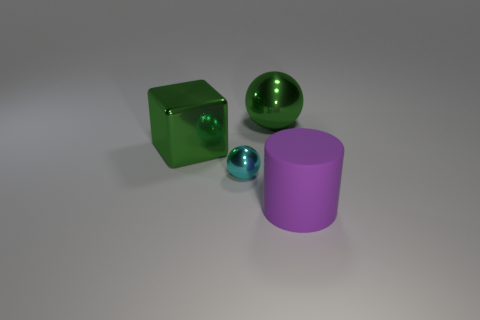Add 3 large purple matte cylinders. How many objects exist? 7 Subtract all green balls. How many balls are left? 1 Subtract all purple blocks. How many blue balls are left? 0 Subtract 2 balls. How many balls are left? 0 Subtract all brown spheres. Subtract all brown cubes. How many spheres are left? 2 Subtract all purple things. Subtract all cyan balls. How many objects are left? 2 Add 2 big purple cylinders. How many big purple cylinders are left? 3 Add 2 purple matte cylinders. How many purple matte cylinders exist? 3 Subtract 0 gray cubes. How many objects are left? 4 Subtract all cubes. How many objects are left? 3 